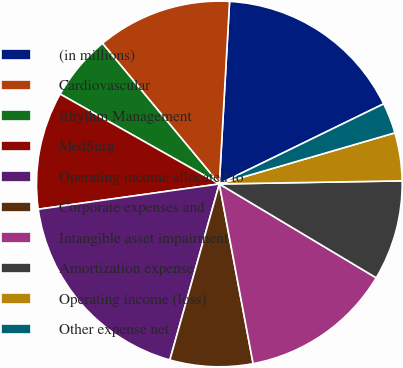Convert chart. <chart><loc_0><loc_0><loc_500><loc_500><pie_chart><fcel>(in millions)<fcel>Cardiovascular<fcel>Rhythm Management<fcel>MedSurg<fcel>Operating income allocated to<fcel>Corporate expenses and<fcel>Intangible asset impairment<fcel>Amortization expense<fcel>Operating income (loss)<fcel>Other expense net<nl><fcel>16.89%<fcel>11.93%<fcel>5.78%<fcel>10.39%<fcel>18.43%<fcel>7.32%<fcel>13.46%<fcel>8.85%<fcel>4.24%<fcel>2.71%<nl></chart> 